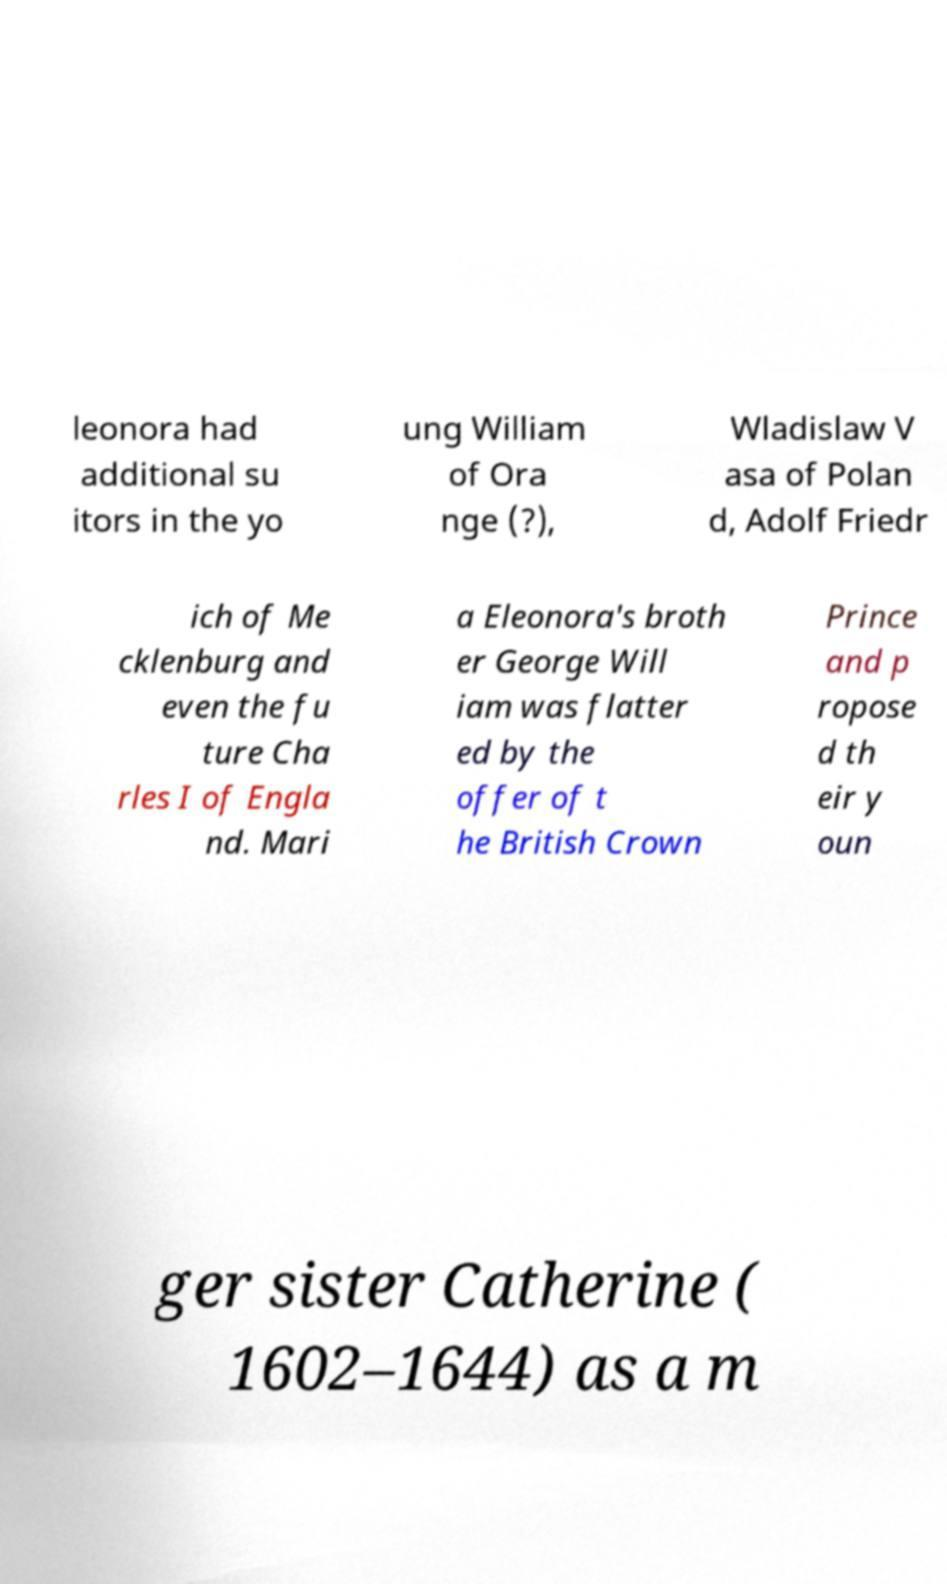For documentation purposes, I need the text within this image transcribed. Could you provide that? leonora had additional su itors in the yo ung William of Ora nge (?), Wladislaw V asa of Polan d, Adolf Friedr ich of Me cklenburg and even the fu ture Cha rles I of Engla nd. Mari a Eleonora's broth er George Will iam was flatter ed by the offer of t he British Crown Prince and p ropose d th eir y oun ger sister Catherine ( 1602–1644) as a m 